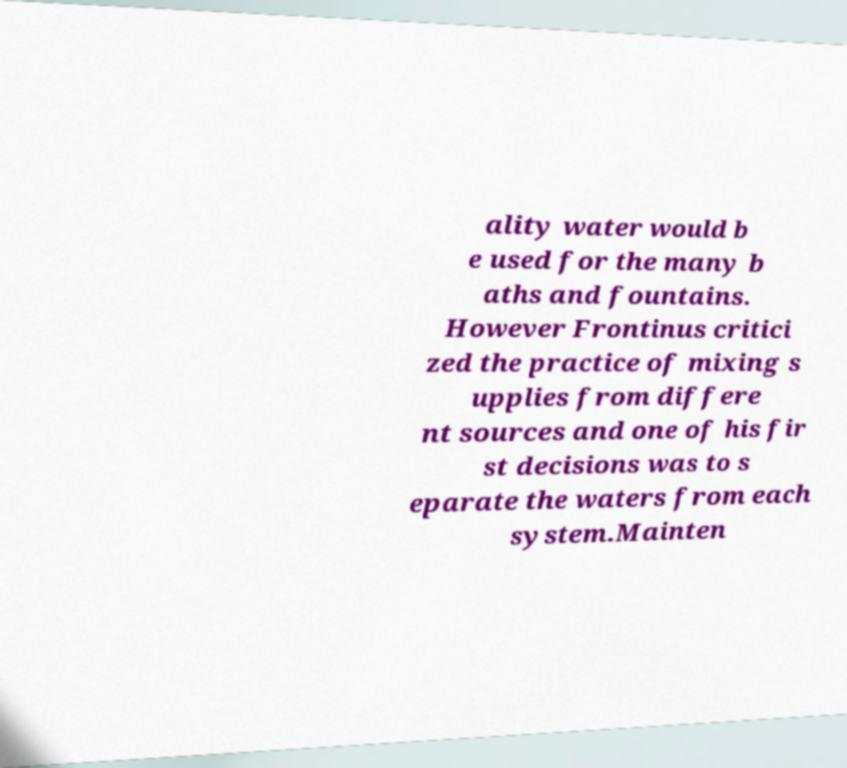Can you accurately transcribe the text from the provided image for me? ality water would b e used for the many b aths and fountains. However Frontinus critici zed the practice of mixing s upplies from differe nt sources and one of his fir st decisions was to s eparate the waters from each system.Mainten 